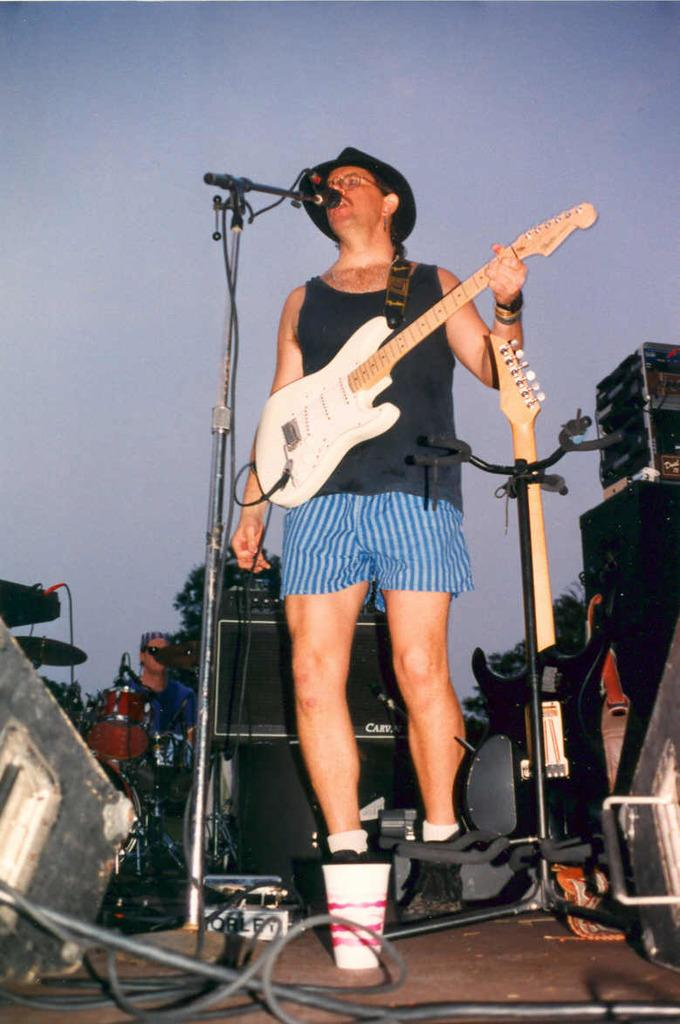What is the man in the image doing? The man is singing in the image. What is the man holding while singing? The man is holding a microphone and a guitar. What other items related to music can be seen in the image? There are musical instruments and speakers in the image. What type of locket is the man wearing around his neck in the image? There is no locket visible around the man's neck in the image. Can you tell me how many pets are present in the image? There are no pets visible in the image. 